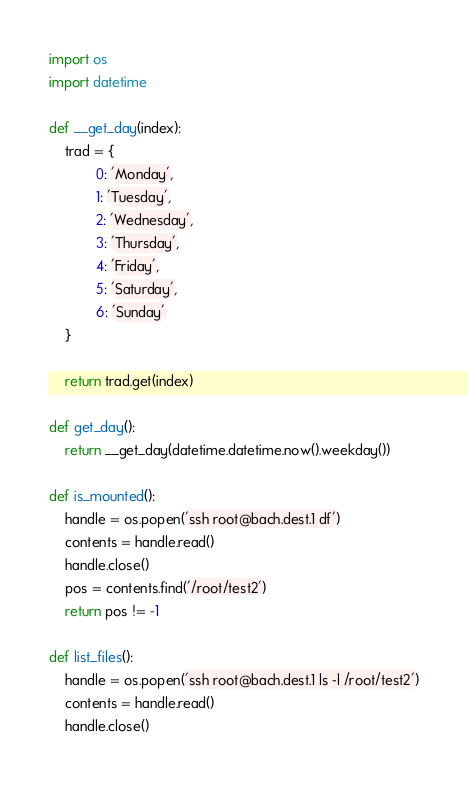Convert code to text. <code><loc_0><loc_0><loc_500><loc_500><_Python_>import os
import datetime

def __get_day(index):
    trad = {
            0: 'Monday',
            1: 'Tuesday',
            2: 'Wednesday',
            3: 'Thursday',
            4: 'Friday',
            5: 'Saturday',
            6: 'Sunday'
    }

    return trad.get(index)

def get_day():
    return __get_day(datetime.datetime.now().weekday())

def is_mounted():
    handle = os.popen('ssh root@bach.dest.1 df')
    contents = handle.read()
    handle.close()
    pos = contents.find('/root/test2')
    return pos != -1

def list_files():
    handle = os.popen('ssh root@bach.dest.1 ls -l /root/test2')
    contents = handle.read()
    handle.close()</code> 